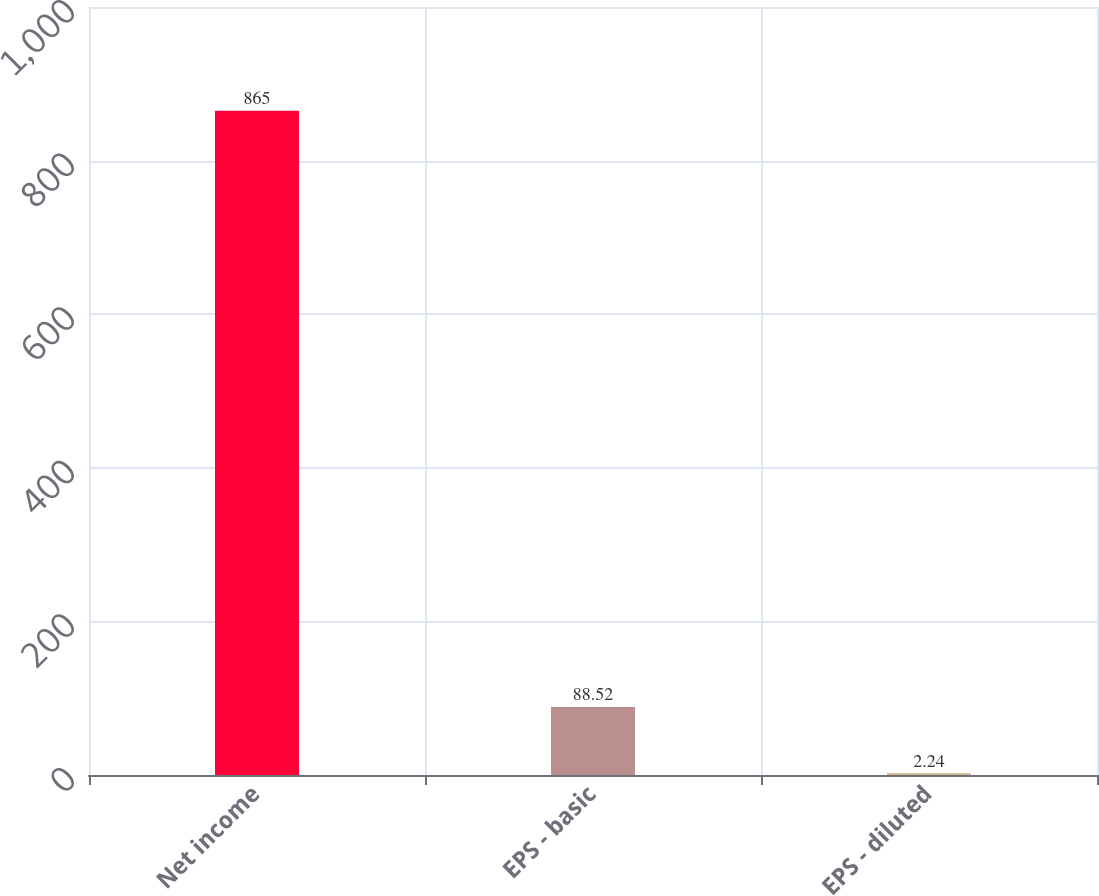<chart> <loc_0><loc_0><loc_500><loc_500><bar_chart><fcel>Net income<fcel>EPS - basic<fcel>EPS - diluted<nl><fcel>865<fcel>88.52<fcel>2.24<nl></chart> 